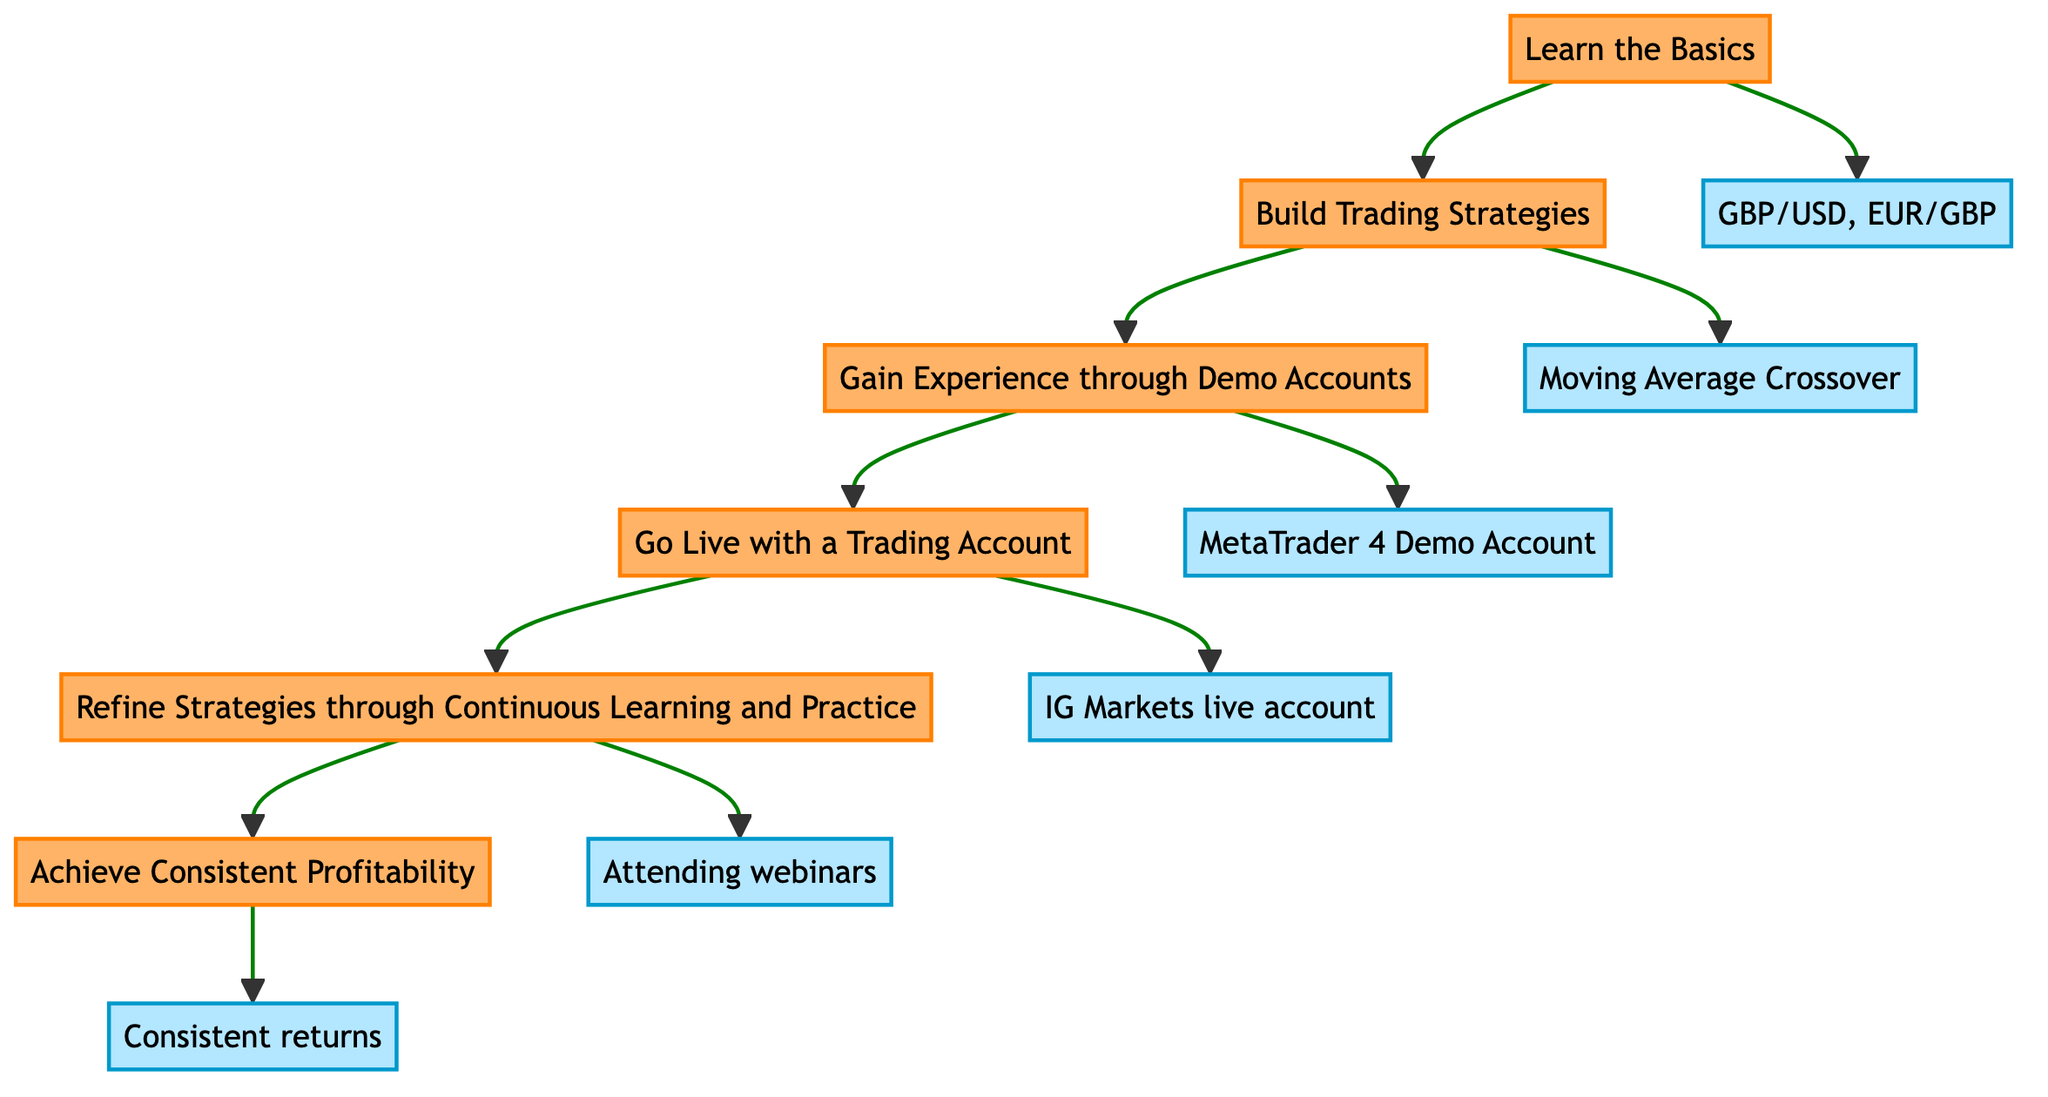What's the first stage in the pathway? The first stage is represented at the bottom of the flow chart and is labeled "Learn the Basics."
Answer: Learn the Basics How many stages are there in total? Counting each stage from the bottom to the top, there are six stages listed in the diagram.
Answer: Six Which stage comes immediately after "Gain Experience through Demo Accounts"? The stage that follows "Gain Experience through Demo Accounts" is indicated by the arrow pointing upward and is labeled "Go Live with a Trading Account."
Answer: Go Live with a Trading Account What is described in the stage titled "Refine Strategies through Continuous Learning and Practice"? The stage includes the description of regularly updating and refining trading strategies based on market changes and new knowledge.
Answer: Regularly updating and refining strategies Which icon represents the "Achieve Consistent Profitability" stage? The stage labeled "Achieve Consistent Profitability" is indicated by the icon of a money bag, which symbolizes financial success.
Answer: 💰 What examples are given for the "Build Trading Strategies" stage? The examples provided for this stage include "Moving Average Crossover" and "Support and Resistance," which are common trading strategies.
Answer: Moving Average Crossover, Support and Resistance If a trader successfully completes the "Go Live with a Trading Account" stage, what is the next logical step? The logical next step after going live with a trading account, as indicated by the flow of the diagram, is to "Refine Strategies through Continuous Learning and Practice."
Answer: Refine Strategies through Continuous Learning and Practice What is the relationship between "Learn the Basics" and "Achieve Consistent Profitability"? The relationship is linear as "Learn the Basics" is the starting point, and "Achieve Consistent Profitability" is the final outcome after progressing through all the stages.
Answer: Linear progression What type of accounts are mentioned in the "Gain Experience through Demo Accounts" stage? The accounts mentioned in this stage are demo accounts used for practicing trades without financial risk.
Answer: Demo accounts 